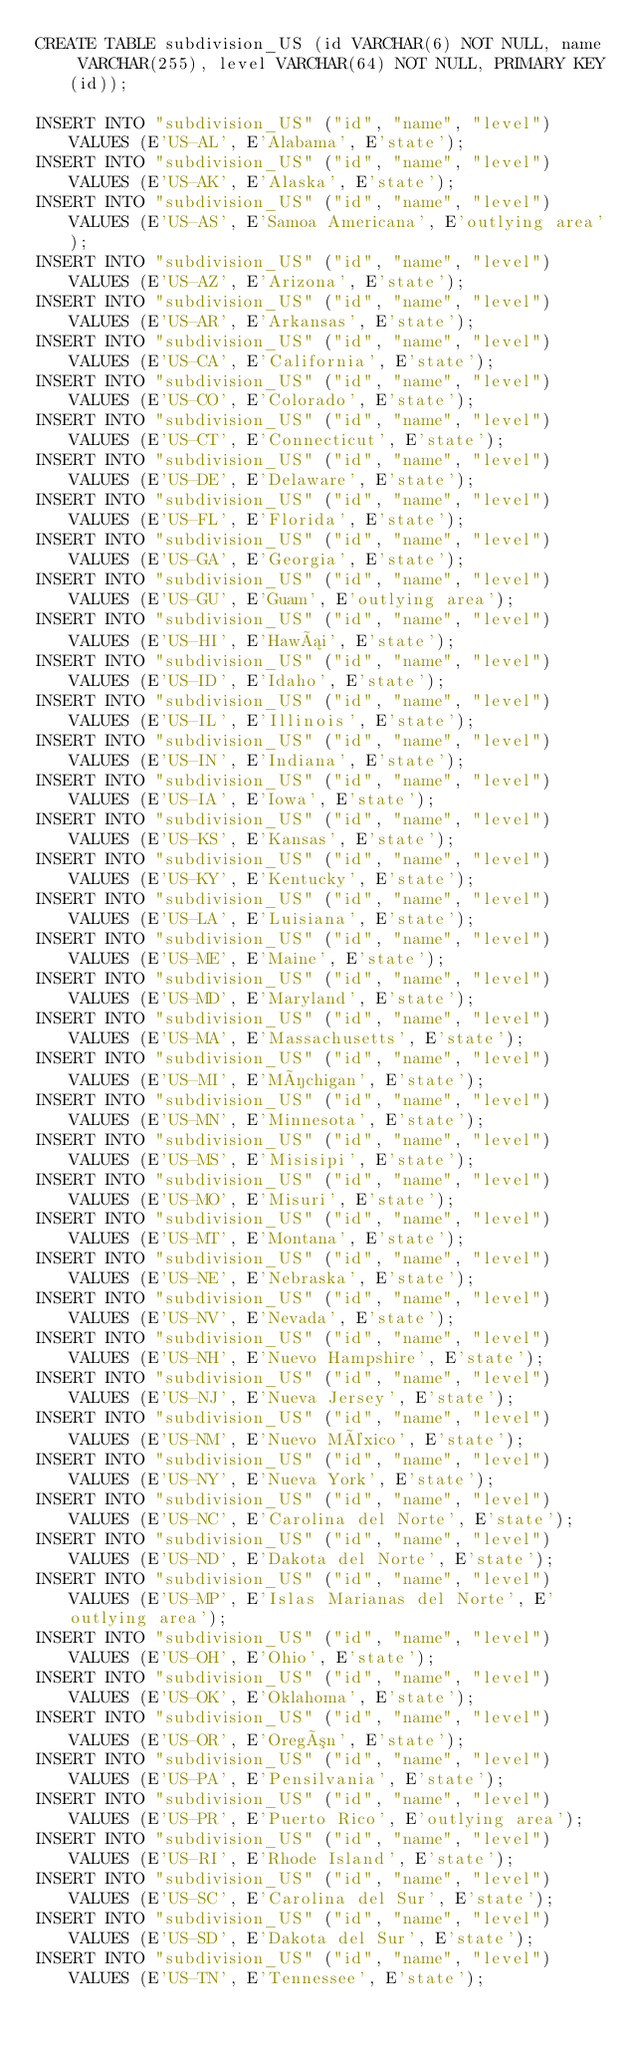<code> <loc_0><loc_0><loc_500><loc_500><_SQL_>CREATE TABLE subdivision_US (id VARCHAR(6) NOT NULL, name VARCHAR(255), level VARCHAR(64) NOT NULL, PRIMARY KEY(id));

INSERT INTO "subdivision_US" ("id", "name", "level") VALUES (E'US-AL', E'Alabama', E'state');
INSERT INTO "subdivision_US" ("id", "name", "level") VALUES (E'US-AK', E'Alaska', E'state');
INSERT INTO "subdivision_US" ("id", "name", "level") VALUES (E'US-AS', E'Samoa Americana', E'outlying area');
INSERT INTO "subdivision_US" ("id", "name", "level") VALUES (E'US-AZ', E'Arizona', E'state');
INSERT INTO "subdivision_US" ("id", "name", "level") VALUES (E'US-AR', E'Arkansas', E'state');
INSERT INTO "subdivision_US" ("id", "name", "level") VALUES (E'US-CA', E'California', E'state');
INSERT INTO "subdivision_US" ("id", "name", "level") VALUES (E'US-CO', E'Colorado', E'state');
INSERT INTO "subdivision_US" ("id", "name", "level") VALUES (E'US-CT', E'Connecticut', E'state');
INSERT INTO "subdivision_US" ("id", "name", "level") VALUES (E'US-DE', E'Delaware', E'state');
INSERT INTO "subdivision_US" ("id", "name", "level") VALUES (E'US-FL', E'Florida', E'state');
INSERT INTO "subdivision_US" ("id", "name", "level") VALUES (E'US-GA', E'Georgia', E'state');
INSERT INTO "subdivision_US" ("id", "name", "level") VALUES (E'US-GU', E'Guam', E'outlying area');
INSERT INTO "subdivision_US" ("id", "name", "level") VALUES (E'US-HI', E'Hawái', E'state');
INSERT INTO "subdivision_US" ("id", "name", "level") VALUES (E'US-ID', E'Idaho', E'state');
INSERT INTO "subdivision_US" ("id", "name", "level") VALUES (E'US-IL', E'Illinois', E'state');
INSERT INTO "subdivision_US" ("id", "name", "level") VALUES (E'US-IN', E'Indiana', E'state');
INSERT INTO "subdivision_US" ("id", "name", "level") VALUES (E'US-IA', E'Iowa', E'state');
INSERT INTO "subdivision_US" ("id", "name", "level") VALUES (E'US-KS', E'Kansas', E'state');
INSERT INTO "subdivision_US" ("id", "name", "level") VALUES (E'US-KY', E'Kentucky', E'state');
INSERT INTO "subdivision_US" ("id", "name", "level") VALUES (E'US-LA', E'Luisiana', E'state');
INSERT INTO "subdivision_US" ("id", "name", "level") VALUES (E'US-ME', E'Maine', E'state');
INSERT INTO "subdivision_US" ("id", "name", "level") VALUES (E'US-MD', E'Maryland', E'state');
INSERT INTO "subdivision_US" ("id", "name", "level") VALUES (E'US-MA', E'Massachusetts', E'state');
INSERT INTO "subdivision_US" ("id", "name", "level") VALUES (E'US-MI', E'Míchigan', E'state');
INSERT INTO "subdivision_US" ("id", "name", "level") VALUES (E'US-MN', E'Minnesota', E'state');
INSERT INTO "subdivision_US" ("id", "name", "level") VALUES (E'US-MS', E'Misisipi', E'state');
INSERT INTO "subdivision_US" ("id", "name", "level") VALUES (E'US-MO', E'Misuri', E'state');
INSERT INTO "subdivision_US" ("id", "name", "level") VALUES (E'US-MT', E'Montana', E'state');
INSERT INTO "subdivision_US" ("id", "name", "level") VALUES (E'US-NE', E'Nebraska', E'state');
INSERT INTO "subdivision_US" ("id", "name", "level") VALUES (E'US-NV', E'Nevada', E'state');
INSERT INTO "subdivision_US" ("id", "name", "level") VALUES (E'US-NH', E'Nuevo Hampshire', E'state');
INSERT INTO "subdivision_US" ("id", "name", "level") VALUES (E'US-NJ', E'Nueva Jersey', E'state');
INSERT INTO "subdivision_US" ("id", "name", "level") VALUES (E'US-NM', E'Nuevo México', E'state');
INSERT INTO "subdivision_US" ("id", "name", "level") VALUES (E'US-NY', E'Nueva York', E'state');
INSERT INTO "subdivision_US" ("id", "name", "level") VALUES (E'US-NC', E'Carolina del Norte', E'state');
INSERT INTO "subdivision_US" ("id", "name", "level") VALUES (E'US-ND', E'Dakota del Norte', E'state');
INSERT INTO "subdivision_US" ("id", "name", "level") VALUES (E'US-MP', E'Islas Marianas del Norte', E'outlying area');
INSERT INTO "subdivision_US" ("id", "name", "level") VALUES (E'US-OH', E'Ohio', E'state');
INSERT INTO "subdivision_US" ("id", "name", "level") VALUES (E'US-OK', E'Oklahoma', E'state');
INSERT INTO "subdivision_US" ("id", "name", "level") VALUES (E'US-OR', E'Oregón', E'state');
INSERT INTO "subdivision_US" ("id", "name", "level") VALUES (E'US-PA', E'Pensilvania', E'state');
INSERT INTO "subdivision_US" ("id", "name", "level") VALUES (E'US-PR', E'Puerto Rico', E'outlying area');
INSERT INTO "subdivision_US" ("id", "name", "level") VALUES (E'US-RI', E'Rhode Island', E'state');
INSERT INTO "subdivision_US" ("id", "name", "level") VALUES (E'US-SC', E'Carolina del Sur', E'state');
INSERT INTO "subdivision_US" ("id", "name", "level") VALUES (E'US-SD', E'Dakota del Sur', E'state');
INSERT INTO "subdivision_US" ("id", "name", "level") VALUES (E'US-TN', E'Tennessee', E'state');</code> 